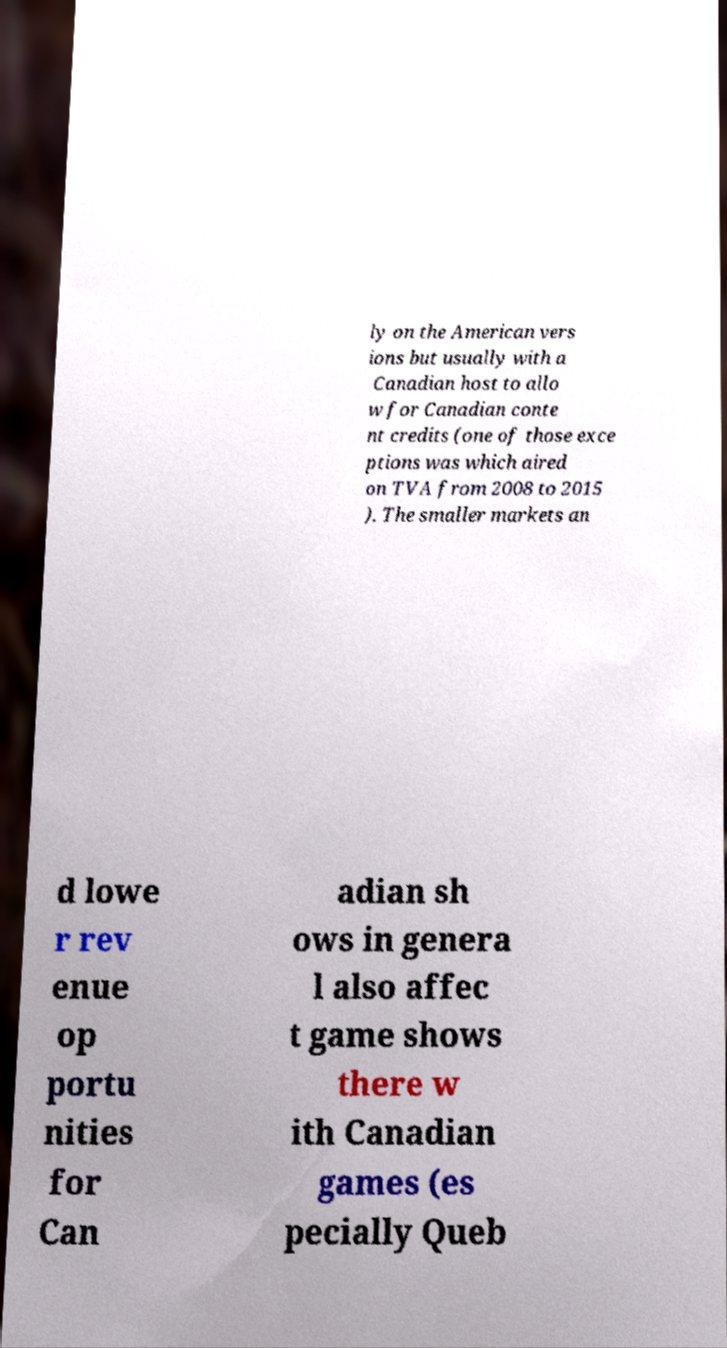Can you accurately transcribe the text from the provided image for me? ly on the American vers ions but usually with a Canadian host to allo w for Canadian conte nt credits (one of those exce ptions was which aired on TVA from 2008 to 2015 ). The smaller markets an d lowe r rev enue op portu nities for Can adian sh ows in genera l also affec t game shows there w ith Canadian games (es pecially Queb 